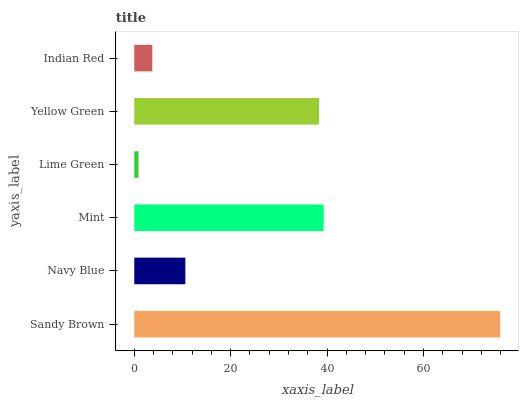Is Lime Green the minimum?
Answer yes or no. Yes. Is Sandy Brown the maximum?
Answer yes or no. Yes. Is Navy Blue the minimum?
Answer yes or no. No. Is Navy Blue the maximum?
Answer yes or no. No. Is Sandy Brown greater than Navy Blue?
Answer yes or no. Yes. Is Navy Blue less than Sandy Brown?
Answer yes or no. Yes. Is Navy Blue greater than Sandy Brown?
Answer yes or no. No. Is Sandy Brown less than Navy Blue?
Answer yes or no. No. Is Yellow Green the high median?
Answer yes or no. Yes. Is Navy Blue the low median?
Answer yes or no. Yes. Is Sandy Brown the high median?
Answer yes or no. No. Is Sandy Brown the low median?
Answer yes or no. No. 